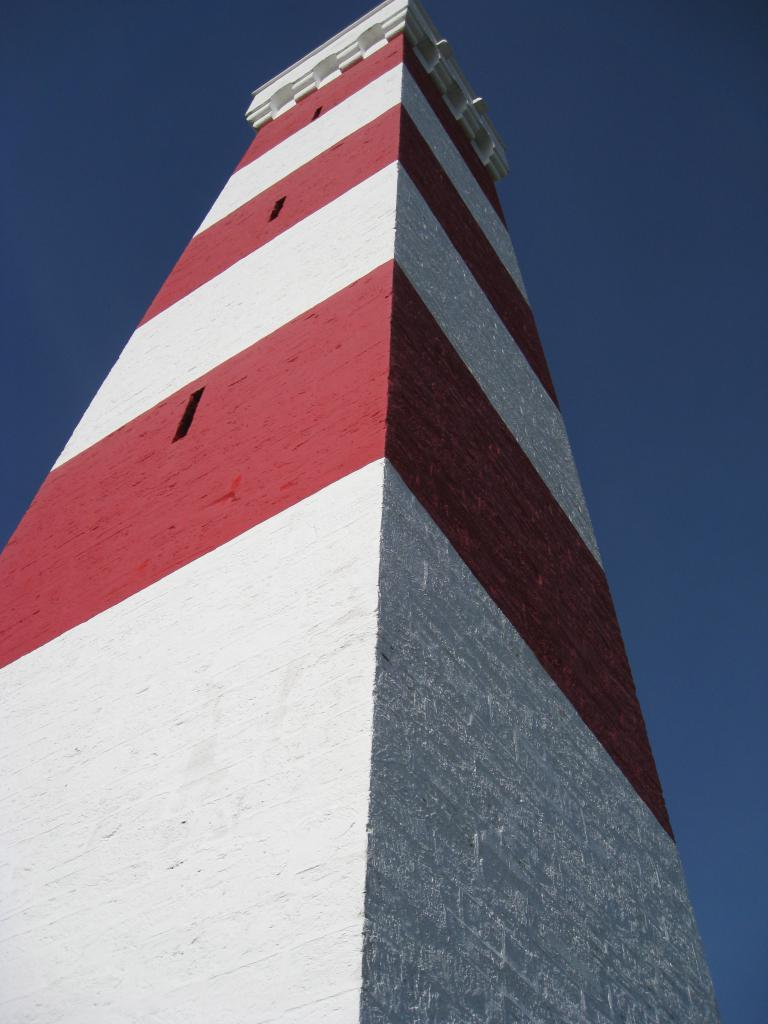What type of structure is present in the image? There is a building in the image. What can be seen above the building in the image? The sky is visible at the top of the image. What type of vegetable is being stitched in the image? There is no vegetable or stitching activity present in the image. 